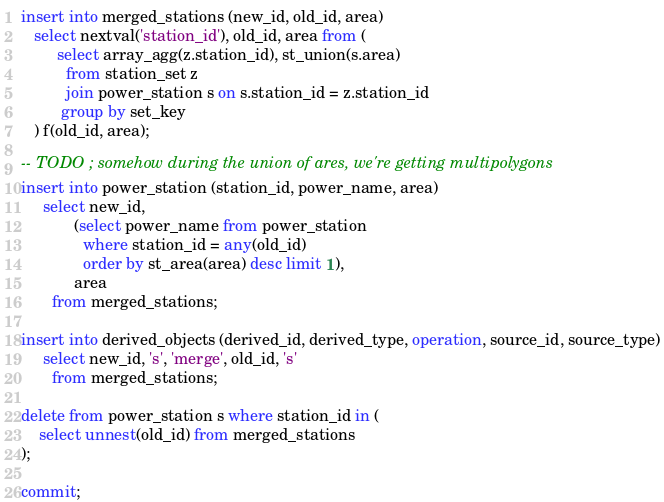<code> <loc_0><loc_0><loc_500><loc_500><_SQL_>
insert into merged_stations (new_id, old_id, area)
   select nextval('station_id'), old_id, area from (
        select array_agg(z.station_id), st_union(s.area)
          from station_set z
          join power_station s on s.station_id = z.station_id
         group by set_key
   ) f(old_id, area);

-- TODO ; somehow during the union of ares, we're getting multipolygons
insert into power_station (station_id, power_name, area)
     select new_id,
            (select power_name from power_station
              where station_id = any(old_id)
              order by st_area(area) desc limit 1),
            area
       from merged_stations;

insert into derived_objects (derived_id, derived_type, operation, source_id, source_type)
     select new_id, 's', 'merge', old_id, 's'
       from merged_stations;

delete from power_station s where station_id in (
    select unnest(old_id) from merged_stations
);

commit;
</code> 